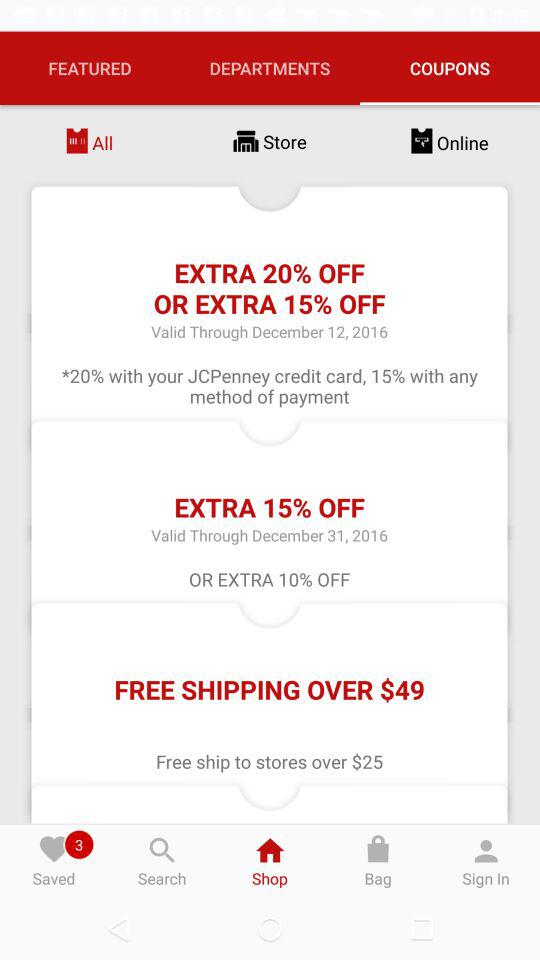How many dollars do I need to spend to get free shipping?
Answer the question using a single word or phrase. $49 